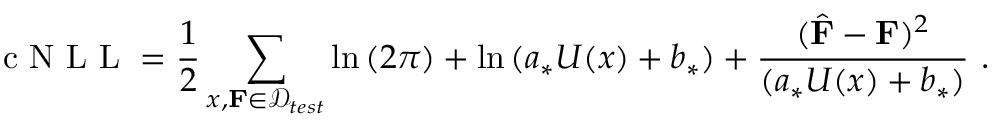<formula> <loc_0><loc_0><loc_500><loc_500>c N L L = \frac { 1 } { 2 } \sum _ { x , F \in \mathcal { D } _ { t e s t } } \ln { ( 2 \pi ) } + \ln { ( a _ { * } U ( x ) + b _ { * } ) } + \frac { ( \hat { F } - F ) ^ { 2 } } { ( a _ { * } U ( x ) + b _ { * } ) } \ .</formula> 